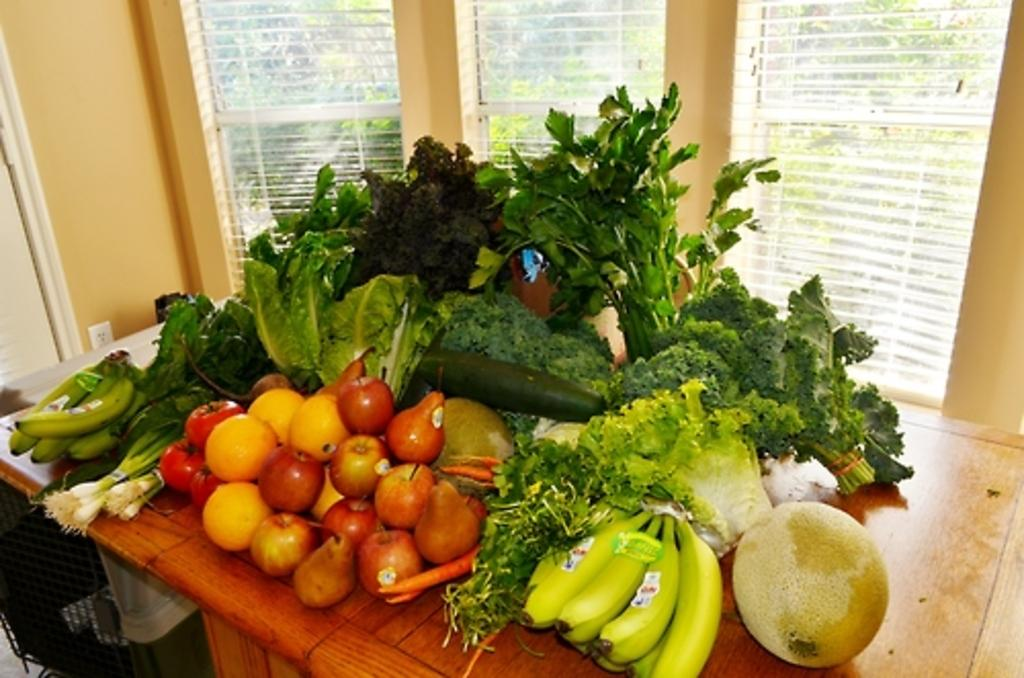What types of food items are visible in the image? There are vegetables and fruits in the image. Where are the vegetables and fruits located? They are kept on a table in the image. What can be seen in the background of the image? There are windows and window blinds visible in the background. What architectural feature is present on the left side of the image? There is a wall with a door on the left side of the image. What type of thread is being used to create the pest in the image? There is no thread or pest present in the image; it features vegetables and fruits on a table with a background of windows and window blinds. 